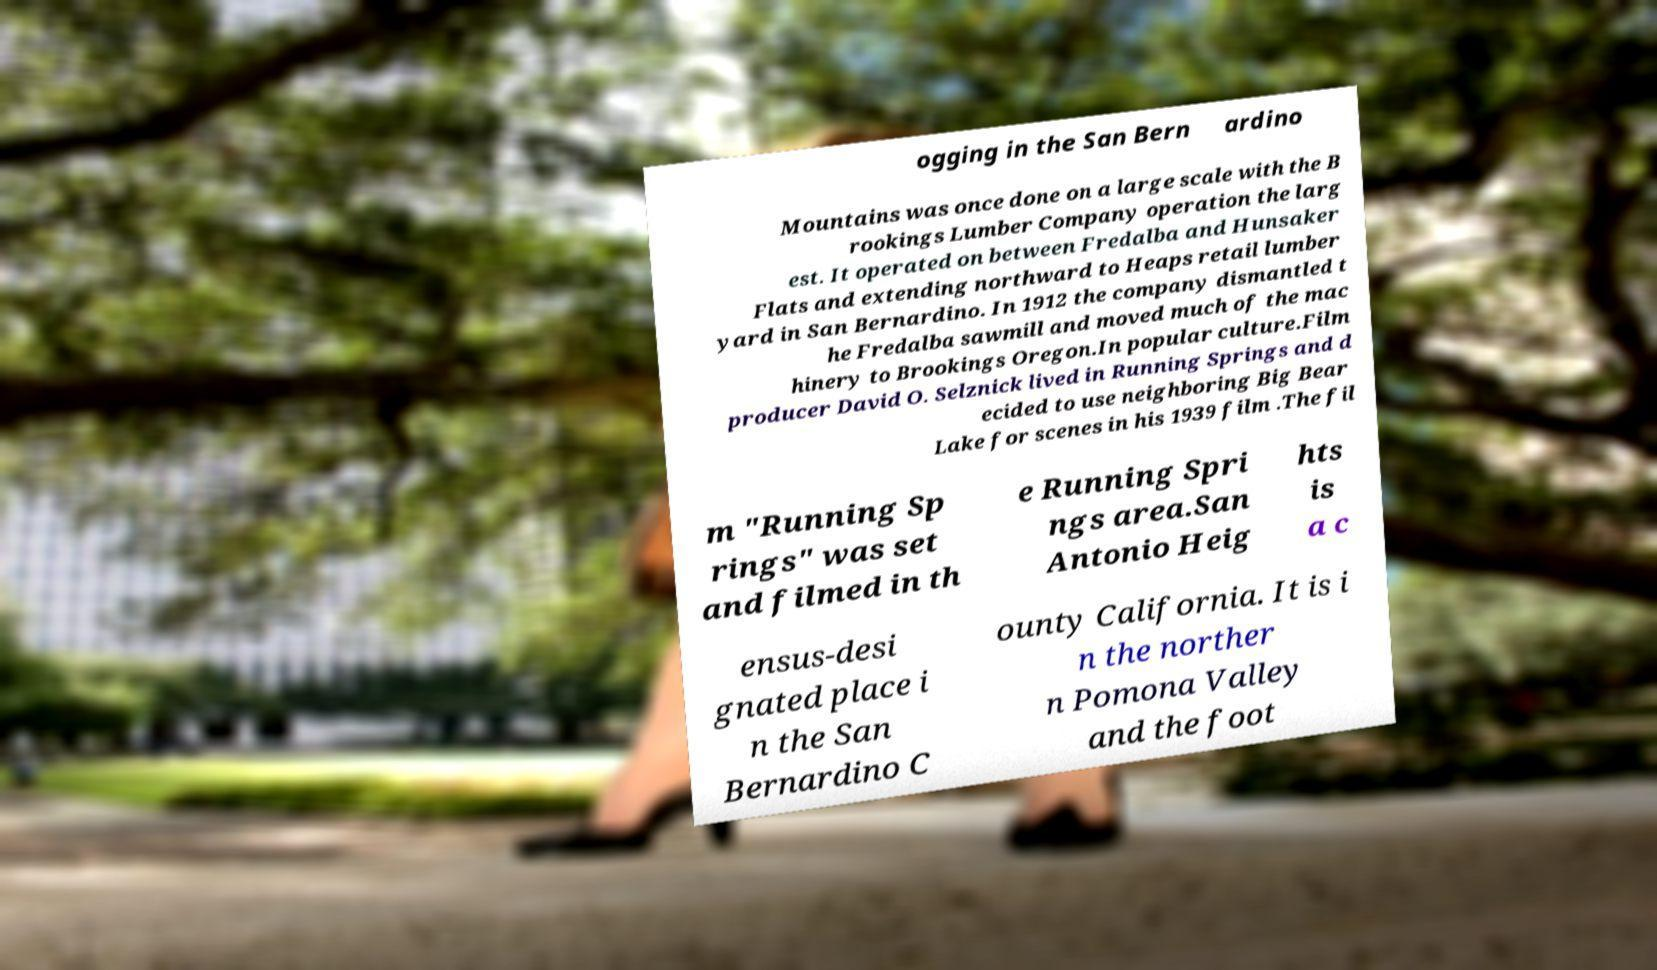Can you accurately transcribe the text from the provided image for me? ogging in the San Bern ardino Mountains was once done on a large scale with the B rookings Lumber Company operation the larg est. It operated on between Fredalba and Hunsaker Flats and extending northward to Heaps retail lumber yard in San Bernardino. In 1912 the company dismantled t he Fredalba sawmill and moved much of the mac hinery to Brookings Oregon.In popular culture.Film producer David O. Selznick lived in Running Springs and d ecided to use neighboring Big Bear Lake for scenes in his 1939 film .The fil m "Running Sp rings" was set and filmed in th e Running Spri ngs area.San Antonio Heig hts is a c ensus-desi gnated place i n the San Bernardino C ounty California. It is i n the norther n Pomona Valley and the foot 